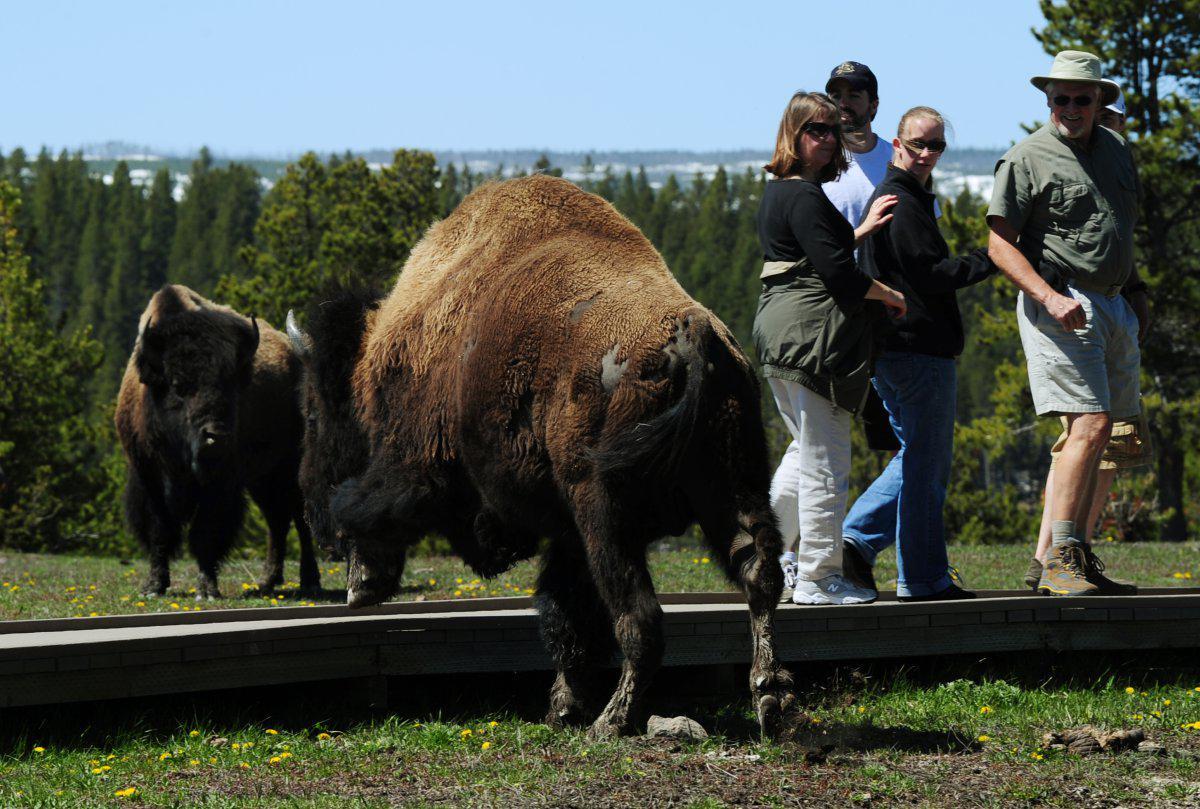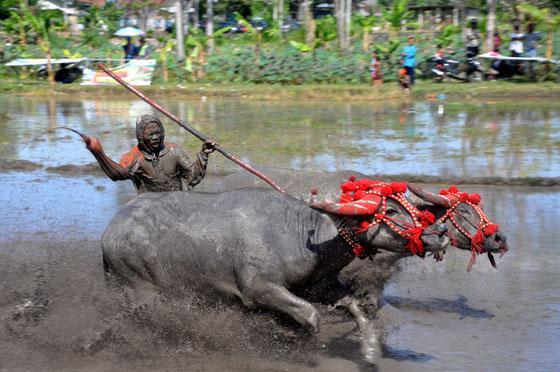The first image is the image on the left, the second image is the image on the right. Given the left and right images, does the statement "A man is holding a whip." hold true? Answer yes or no. Yes. The first image is the image on the left, the second image is the image on the right. Given the left and right images, does the statement "One image is of one man with two beast of burden and the other image has one beast with multiple men." hold true? Answer yes or no. No. 